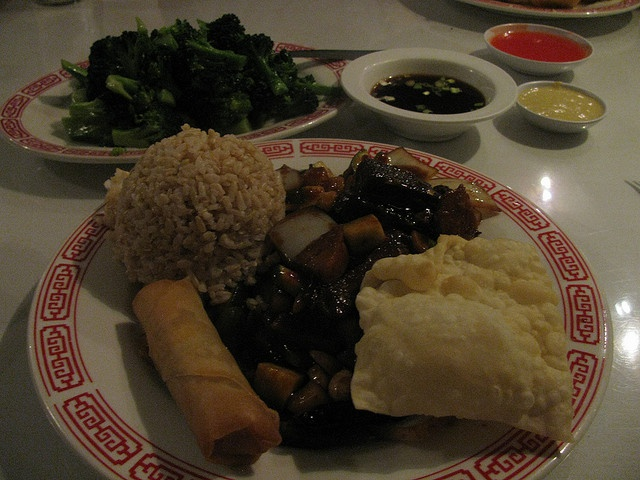Describe the objects in this image and their specific colors. I can see dining table in black and gray tones, broccoli in black, gray, and darkgreen tones, bowl in black, gray, and darkgreen tones, bowl in black, maroon, and gray tones, and bowl in black, olive, and gray tones in this image. 